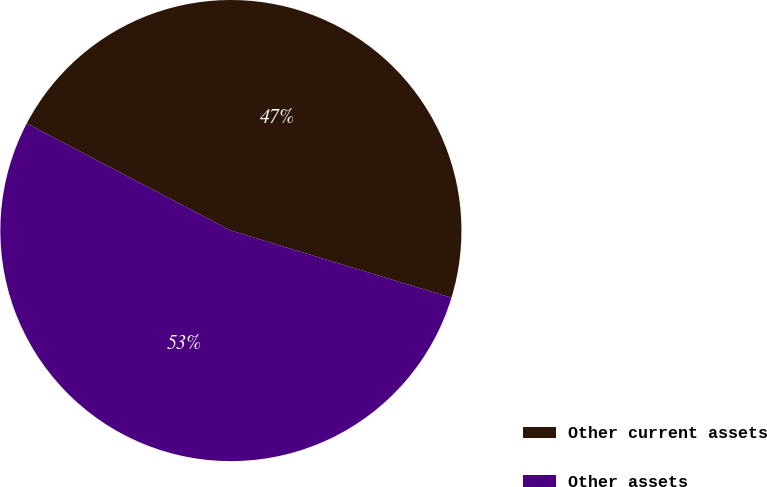Convert chart to OTSL. <chart><loc_0><loc_0><loc_500><loc_500><pie_chart><fcel>Other current assets<fcel>Other assets<nl><fcel>47.01%<fcel>52.99%<nl></chart> 